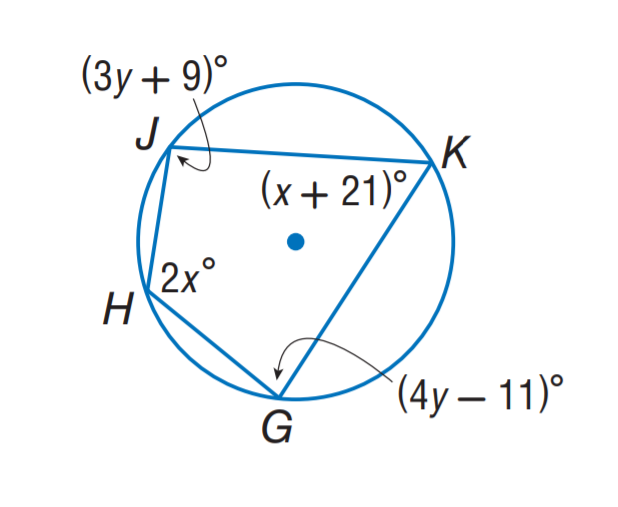Question: Find m \angle H.
Choices:
A. 93
B. 97
C. 106
D. 116
Answer with the letter. Answer: C Question: Find m \angle G.
Choices:
A. 93
B. 97
C. 106
D. 116
Answer with the letter. Answer: A 